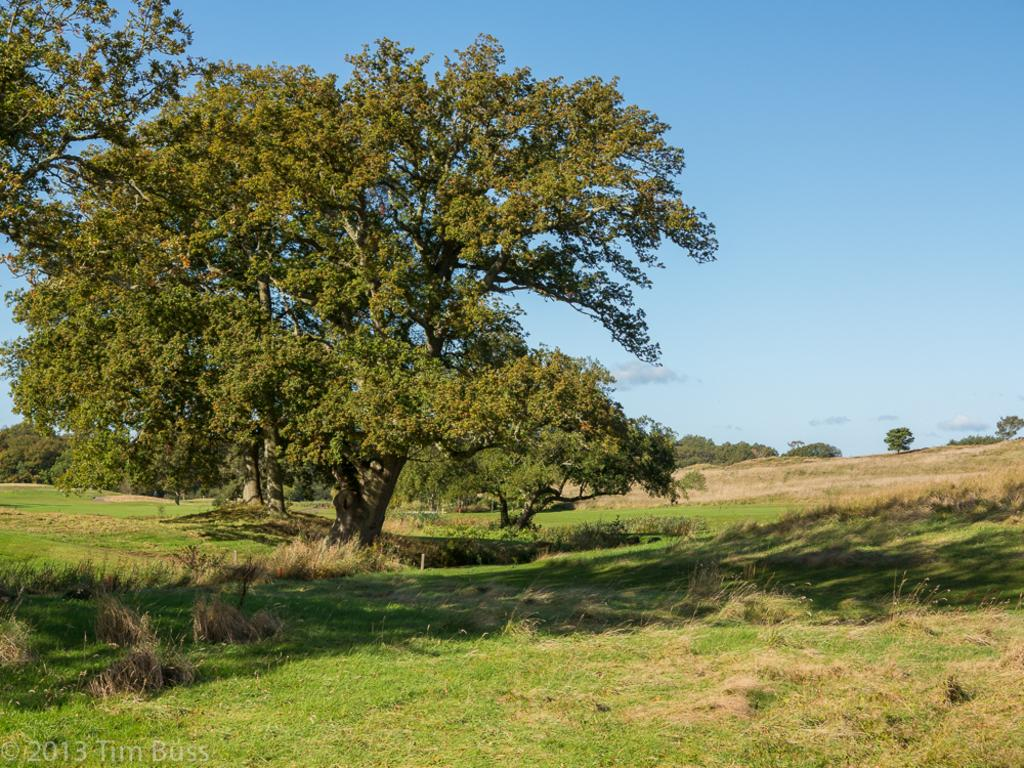What is located on the grassy land in the image? There is a tree on the grassy land in the image. What is visible at the top of the image? The sky is visible at the top of the image. What can be seen in the background of the image? Trees are present in the background of the image. What type of scissors can be seen hanging from the tree in the image? There are no scissors present in the image; it features a tree on grassy land with a visible sky and trees in the background. 